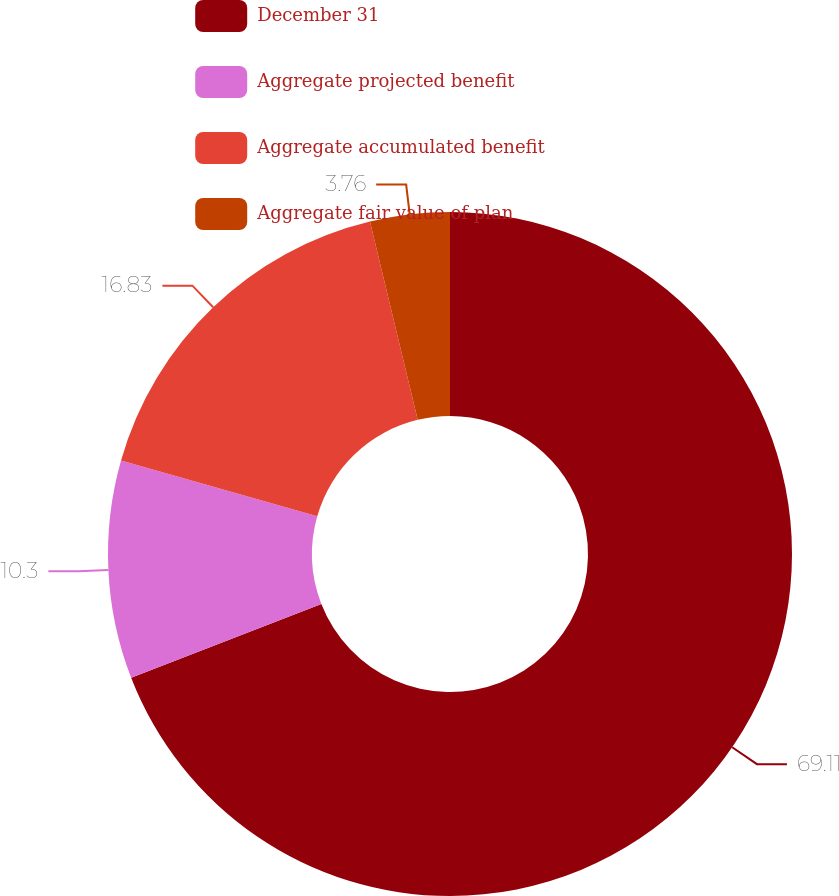Convert chart to OTSL. <chart><loc_0><loc_0><loc_500><loc_500><pie_chart><fcel>December 31<fcel>Aggregate projected benefit<fcel>Aggregate accumulated benefit<fcel>Aggregate fair value of plan<nl><fcel>69.11%<fcel>10.3%<fcel>16.83%<fcel>3.76%<nl></chart> 